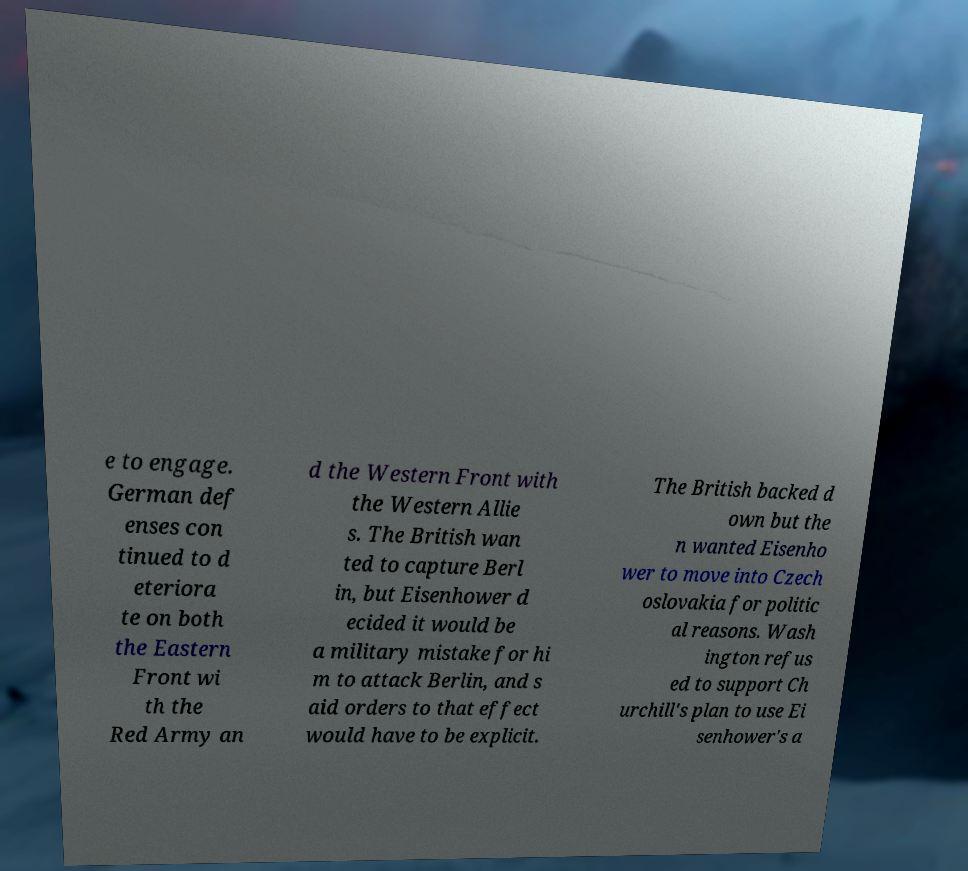There's text embedded in this image that I need extracted. Can you transcribe it verbatim? e to engage. German def enses con tinued to d eteriora te on both the Eastern Front wi th the Red Army an d the Western Front with the Western Allie s. The British wan ted to capture Berl in, but Eisenhower d ecided it would be a military mistake for hi m to attack Berlin, and s aid orders to that effect would have to be explicit. The British backed d own but the n wanted Eisenho wer to move into Czech oslovakia for politic al reasons. Wash ington refus ed to support Ch urchill's plan to use Ei senhower's a 